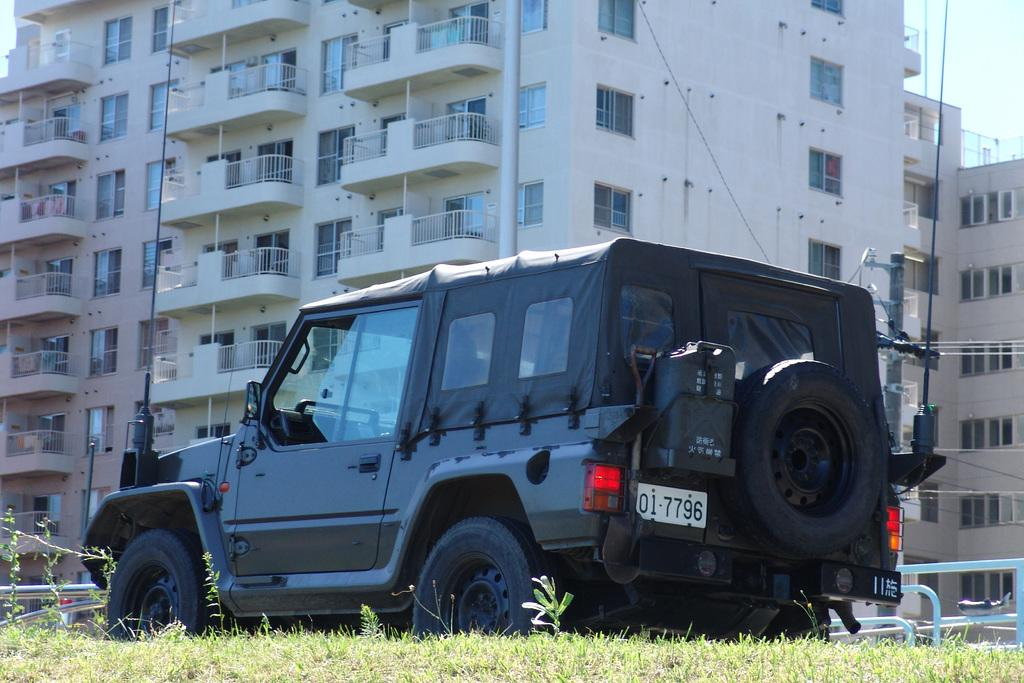What type of structures can be seen in the image? There are buildings in the image. What feature is visible on the buildings? There are windows visible in the image. What type of vegetation is present in the image? There is green grass in the image. What architectural element can be seen in the image? There is a railing in the image. What utility object is present in the image? There is a current pole in the image. What is attached to the current pole? Wires are present in the image. What type of vehicle is visible in the image? There is a black vehicle in the image. How many boys are playing on the level ground near the route in the image? There are no boys present in the image, nor is there any mention of a level ground or a route. 